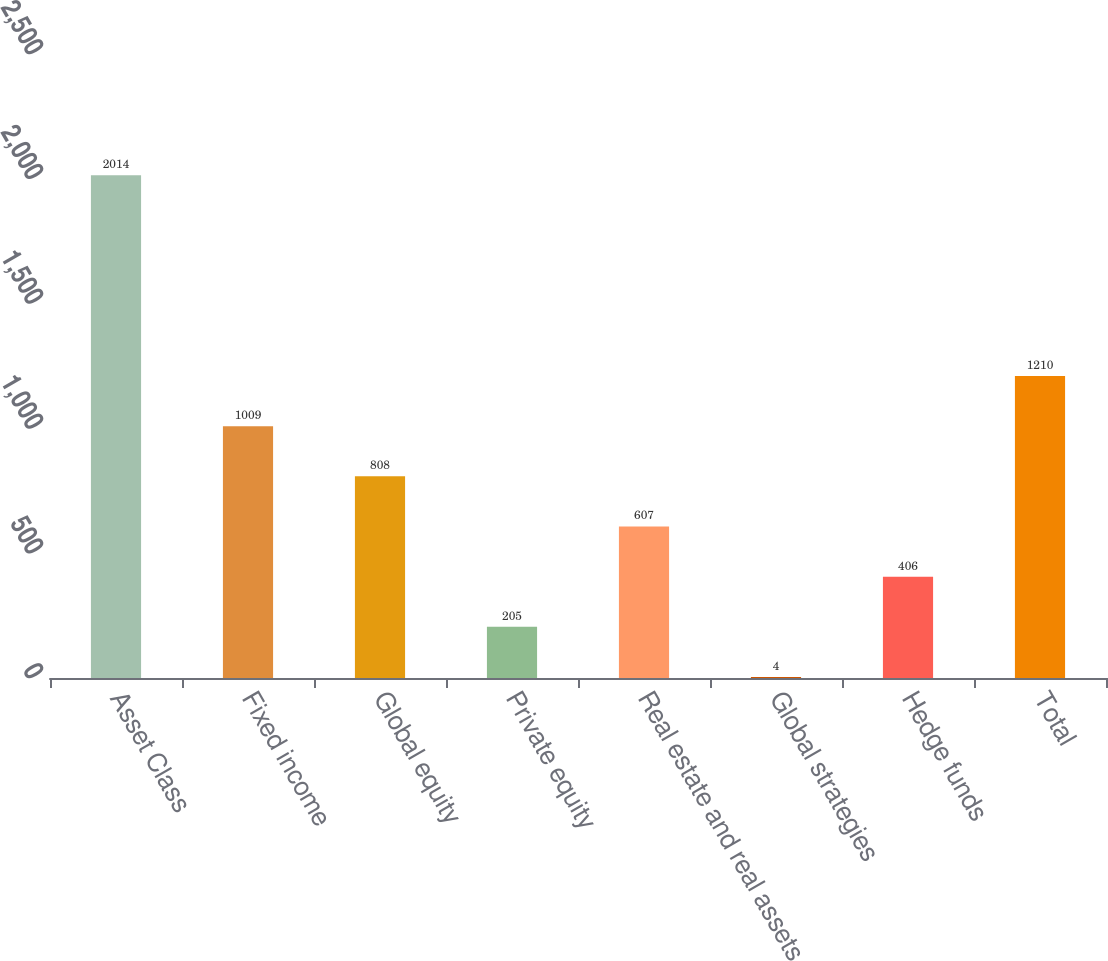Convert chart. <chart><loc_0><loc_0><loc_500><loc_500><bar_chart><fcel>Asset Class<fcel>Fixed income<fcel>Global equity<fcel>Private equity<fcel>Real estate and real assets<fcel>Global strategies<fcel>Hedge funds<fcel>Total<nl><fcel>2014<fcel>1009<fcel>808<fcel>205<fcel>607<fcel>4<fcel>406<fcel>1210<nl></chart> 